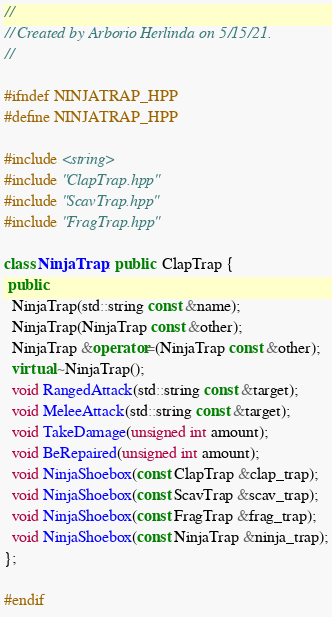Convert code to text. <code><loc_0><loc_0><loc_500><loc_500><_C++_>//
// Created by Arborio Herlinda on 5/15/21.
//

#ifndef NINJATRAP_HPP
#define NINJATRAP_HPP

#include <string>
#include "ClapTrap.hpp"
#include "ScavTrap.hpp"
#include "FragTrap.hpp"

class NinjaTrap : public  ClapTrap {
 public:
  NinjaTrap(std::string const &name);
  NinjaTrap(NinjaTrap const &other);
  NinjaTrap &operator=(NinjaTrap const &other);
  virtual ~NinjaTrap();
  void RangedAttack(std::string const &target);
  void MeleeAttack(std::string const &target);
  void TakeDamage(unsigned int amount);
  void BeRepaired(unsigned int amount);
  void NinjaShoebox(const ClapTrap &clap_trap);
  void NinjaShoebox(const ScavTrap &scav_trap);
  void NinjaShoebox(const FragTrap &frag_trap);
  void NinjaShoebox(const NinjaTrap &ninja_trap);
};

#endif
</code> 